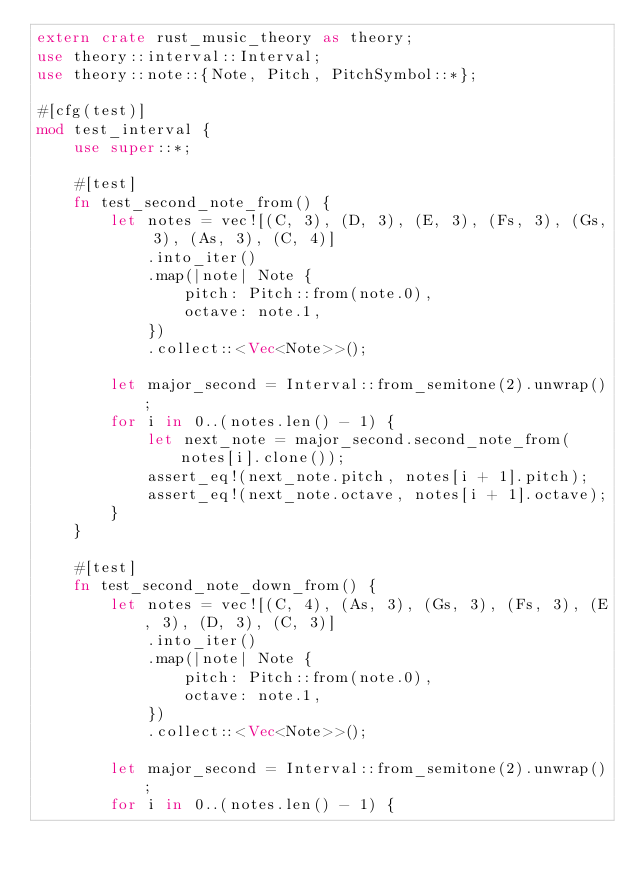<code> <loc_0><loc_0><loc_500><loc_500><_Rust_>extern crate rust_music_theory as theory;
use theory::interval::Interval;
use theory::note::{Note, Pitch, PitchSymbol::*};

#[cfg(test)]
mod test_interval {
    use super::*;

    #[test]
    fn test_second_note_from() {
        let notes = vec![(C, 3), (D, 3), (E, 3), (Fs, 3), (Gs, 3), (As, 3), (C, 4)]
            .into_iter()
            .map(|note| Note {
                pitch: Pitch::from(note.0),
                octave: note.1,
            })
            .collect::<Vec<Note>>();

        let major_second = Interval::from_semitone(2).unwrap();
        for i in 0..(notes.len() - 1) {
            let next_note = major_second.second_note_from(notes[i].clone());
            assert_eq!(next_note.pitch, notes[i + 1].pitch);
            assert_eq!(next_note.octave, notes[i + 1].octave);
        }
    }

    #[test]
    fn test_second_note_down_from() {
        let notes = vec![(C, 4), (As, 3), (Gs, 3), (Fs, 3), (E, 3), (D, 3), (C, 3)]
            .into_iter()
            .map(|note| Note {
                pitch: Pitch::from(note.0),
                octave: note.1,
            })
            .collect::<Vec<Note>>();

        let major_second = Interval::from_semitone(2).unwrap();
        for i in 0..(notes.len() - 1) {</code> 